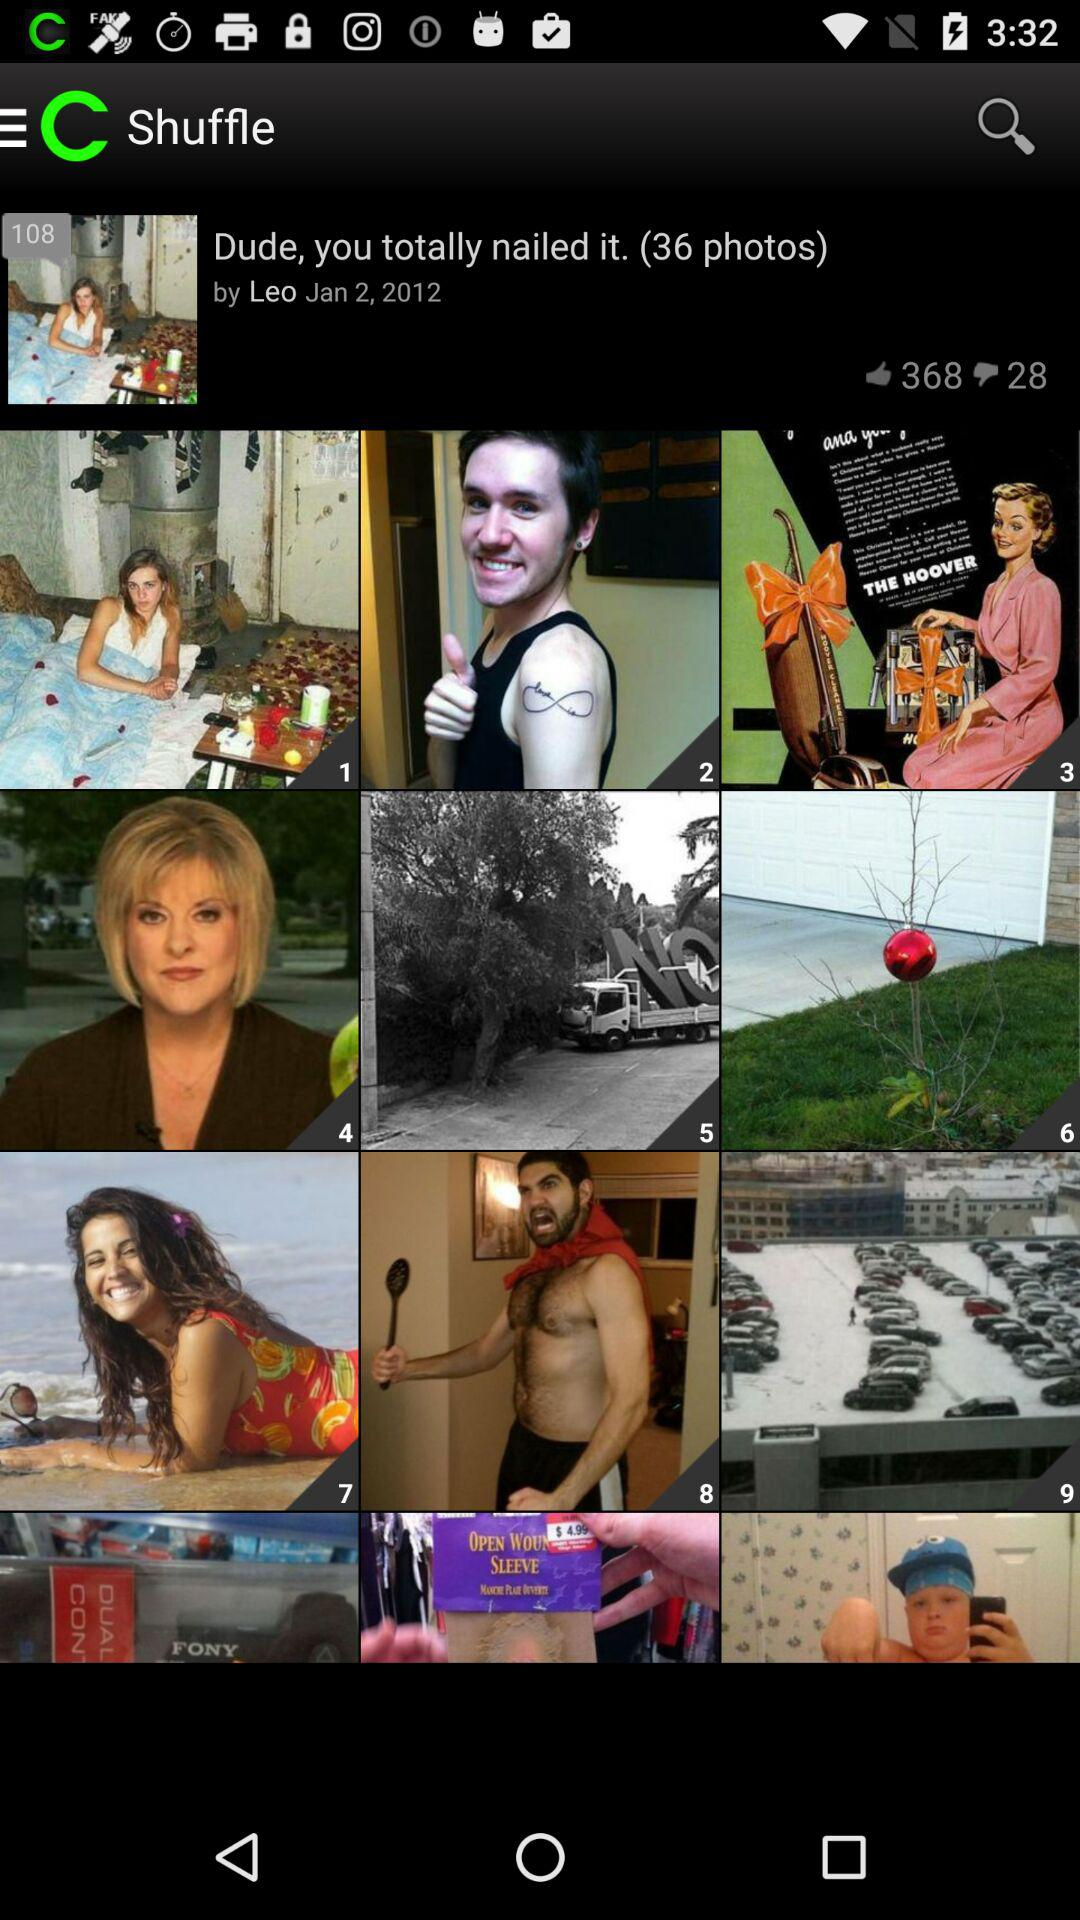What is the total number of photos? The total number of photos is 36. 